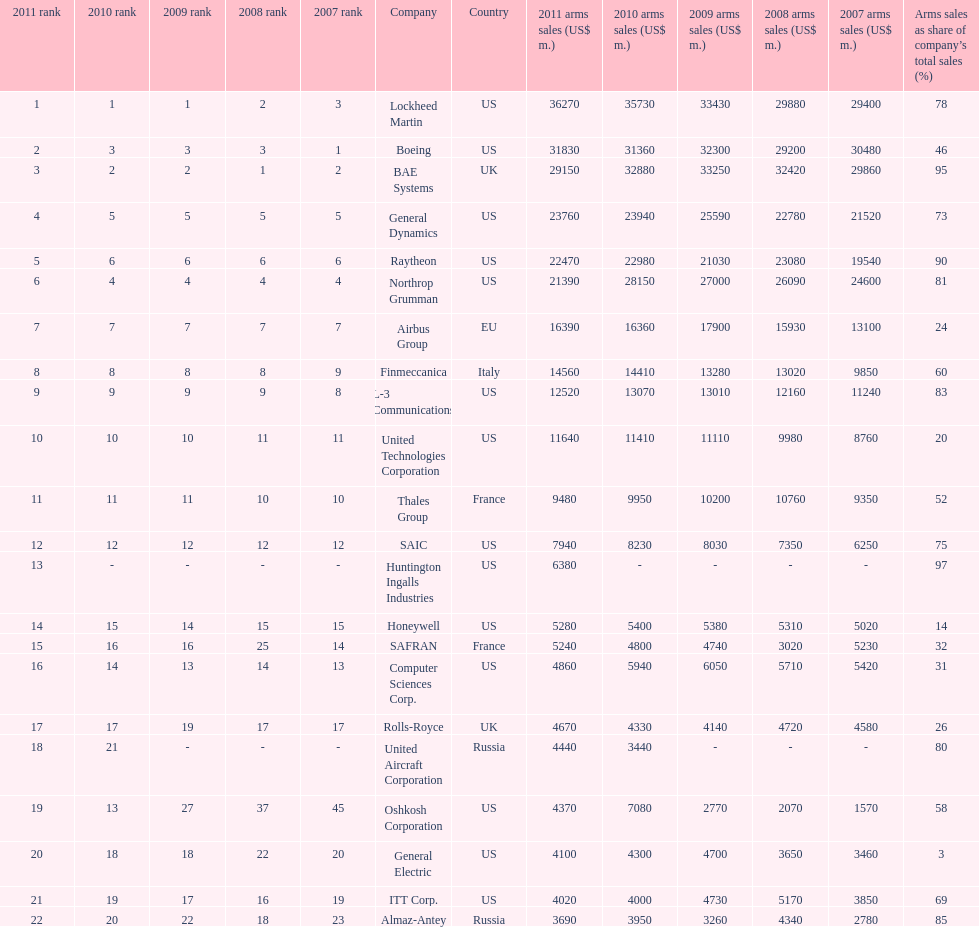In 2010, who has the least amount of sales? United Aircraft Corporation. 